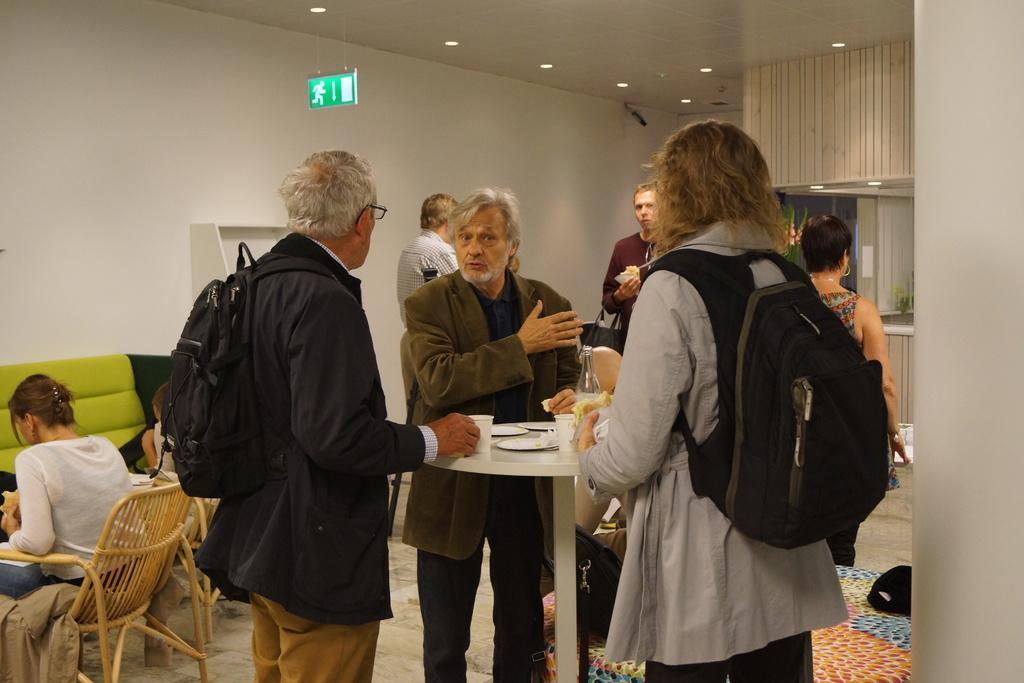Could you give a brief overview of what you see in this image? As we can see in the image there is white color wall, few people standing over here, chairs, sofa and a man who is standing on the right side is wearing bag. 